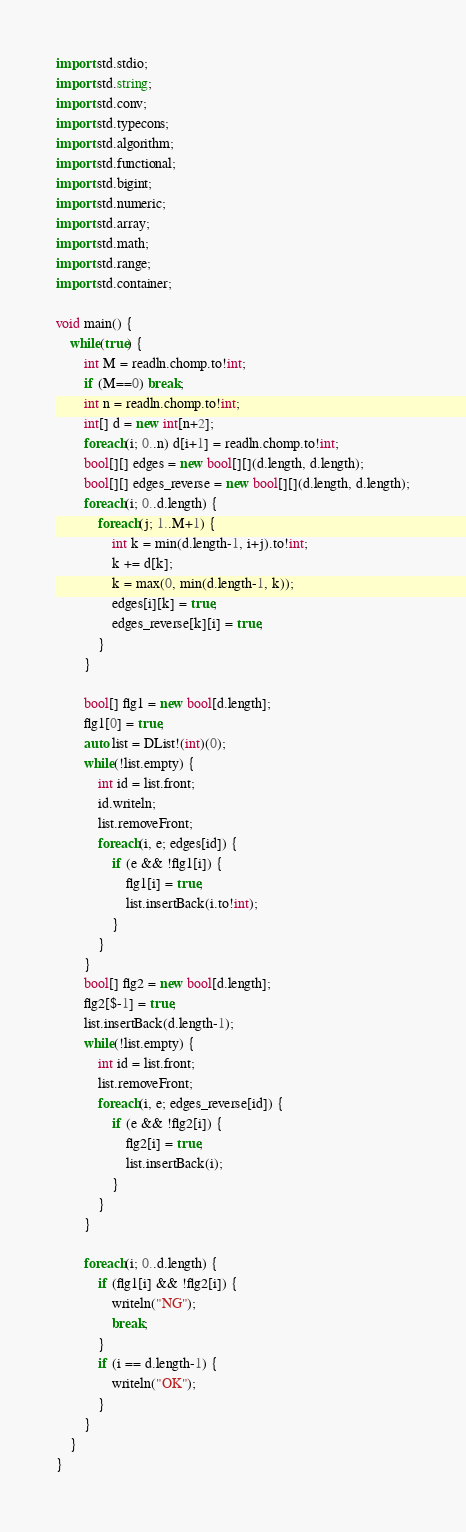Convert code to text. <code><loc_0><loc_0><loc_500><loc_500><_D_>import std.stdio;
import std.string;
import std.conv;
import std.typecons;
import std.algorithm;
import std.functional;
import std.bigint;
import std.numeric;
import std.array;
import std.math;
import std.range;
import std.container;

void main() {
    while(true) {
        int M = readln.chomp.to!int;
        if (M==0) break;
        int n = readln.chomp.to!int;
        int[] d = new int[n+2];
        foreach(i; 0..n) d[i+1] = readln.chomp.to!int;
        bool[][] edges = new bool[][](d.length, d.length);
        bool[][] edges_reverse = new bool[][](d.length, d.length);
        foreach(i; 0..d.length) {
            foreach(j; 1..M+1) {
                int k = min(d.length-1, i+j).to!int;
                k += d[k];
                k = max(0, min(d.length-1, k));
                edges[i][k] = true;
                edges_reverse[k][i] = true;
            }
        }

        bool[] flg1 = new bool[d.length];
        flg1[0] = true;
        auto list = DList!(int)(0);
        while(!list.empty) {
            int id = list.front;
            id.writeln;
            list.removeFront;
            foreach(i, e; edges[id]) {
                if (e && !flg1[i]) {
                    flg1[i] = true;
                    list.insertBack(i.to!int);
                }
            }
        }
        bool[] flg2 = new bool[d.length];
        flg2[$-1] = true;
        list.insertBack(d.length-1);
        while(!list.empty) {
            int id = list.front;
            list.removeFront;
            foreach(i, e; edges_reverse[id]) {
                if (e && !flg2[i]) {
                    flg2[i] = true;
                    list.insertBack(i);
                }
            }
        }

        foreach(i; 0..d.length) {
            if (flg1[i] && !flg2[i]) {
                writeln("NG");
                break;
            }
            if (i == d.length-1) {
                writeln("OK");
            }
        }
    }
}</code> 